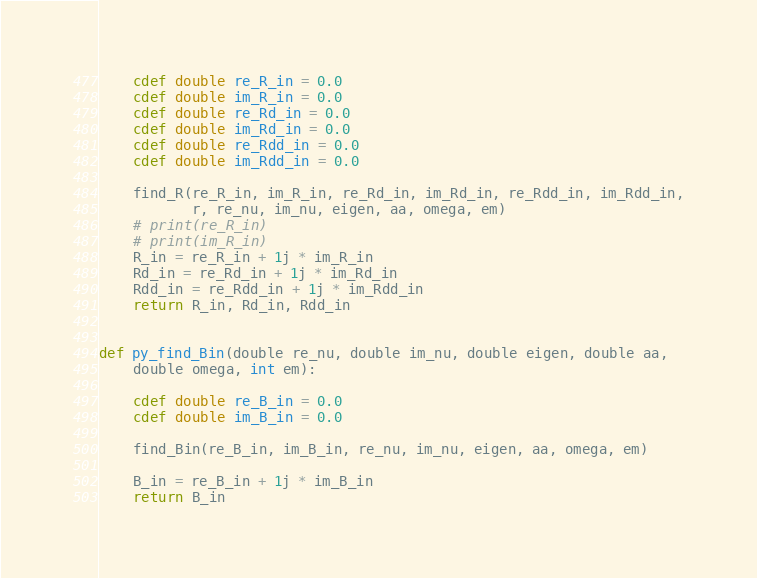<code> <loc_0><loc_0><loc_500><loc_500><_Cython_>
    cdef double re_R_in = 0.0
    cdef double im_R_in = 0.0
    cdef double re_Rd_in = 0.0
    cdef double im_Rd_in = 0.0
    cdef double re_Rdd_in = 0.0
    cdef double im_Rdd_in = 0.0

    find_R(re_R_in, im_R_in, re_Rd_in, im_Rd_in, re_Rdd_in, im_Rdd_in,
           r, re_nu, im_nu, eigen, aa, omega, em)
    # print(re_R_in)
    # print(im_R_in)
    R_in = re_R_in + 1j * im_R_in
    Rd_in = re_Rd_in + 1j * im_Rd_in
    Rdd_in = re_Rdd_in + 1j * im_Rdd_in
    return R_in, Rd_in, Rdd_in


def py_find_Bin(double re_nu, double im_nu, double eigen, double aa,
    double omega, int em):

    cdef double re_B_in = 0.0
    cdef double im_B_in = 0.0

    find_Bin(re_B_in, im_B_in, re_nu, im_nu, eigen, aa, omega, em)

    B_in = re_B_in + 1j * im_B_in
    return B_in
</code> 